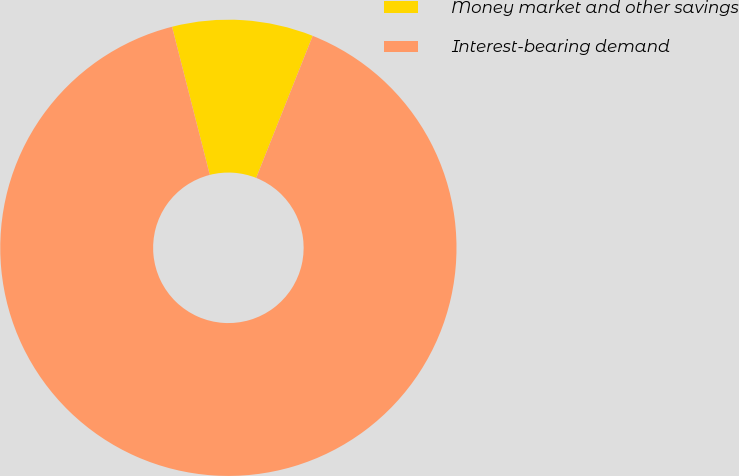Convert chart to OTSL. <chart><loc_0><loc_0><loc_500><loc_500><pie_chart><fcel>Money market and other savings<fcel>Interest-bearing demand<nl><fcel>10.0%<fcel>90.0%<nl></chart> 